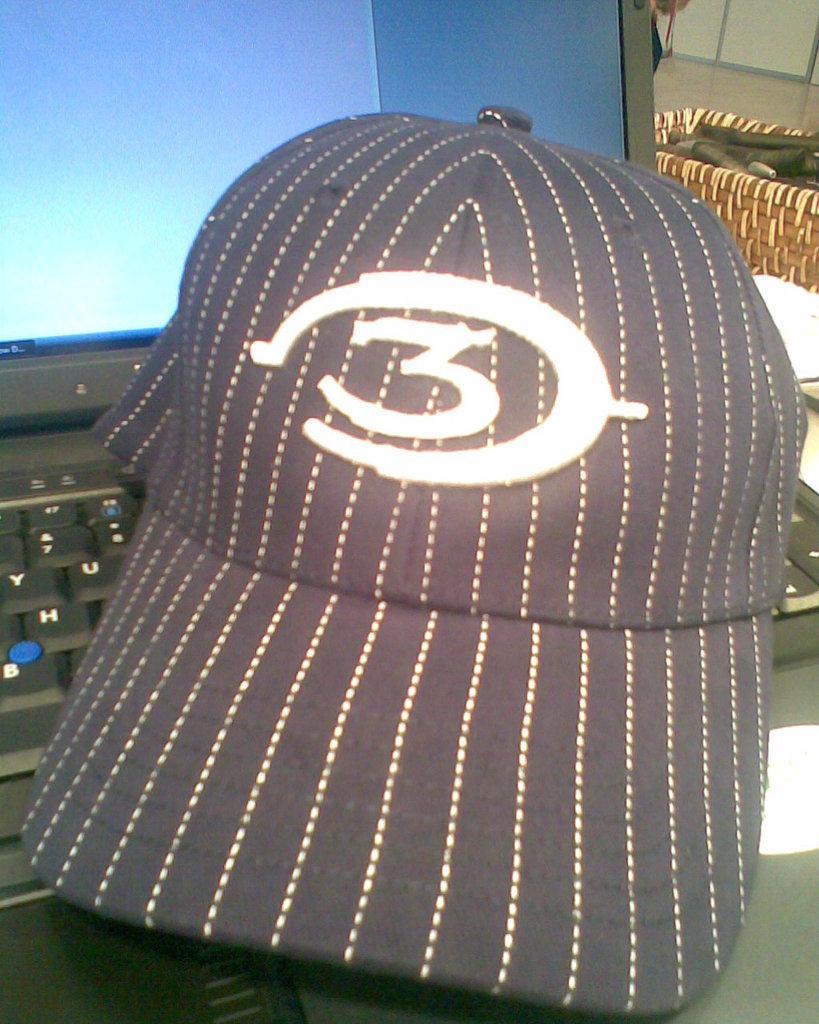Describe this image in one or two sentences. In this image in the front there is a cap with some number which is on the laptop. In the background there is a basket and on the basket there is an object which is black in colour and there is a wall and on the top of the wall there is glass and behind the laptop there is are objects. 